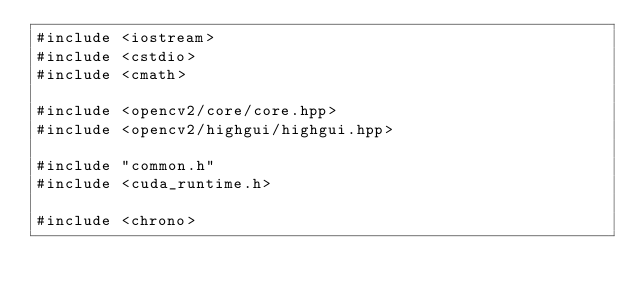Convert code to text. <code><loc_0><loc_0><loc_500><loc_500><_Cuda_>#include <iostream>
#include <cstdio>
#include <cmath>

#include <opencv2/core/core.hpp>
#include <opencv2/highgui/highgui.hpp>

#include "common.h"
#include <cuda_runtime.h>

#include <chrono>
</code> 